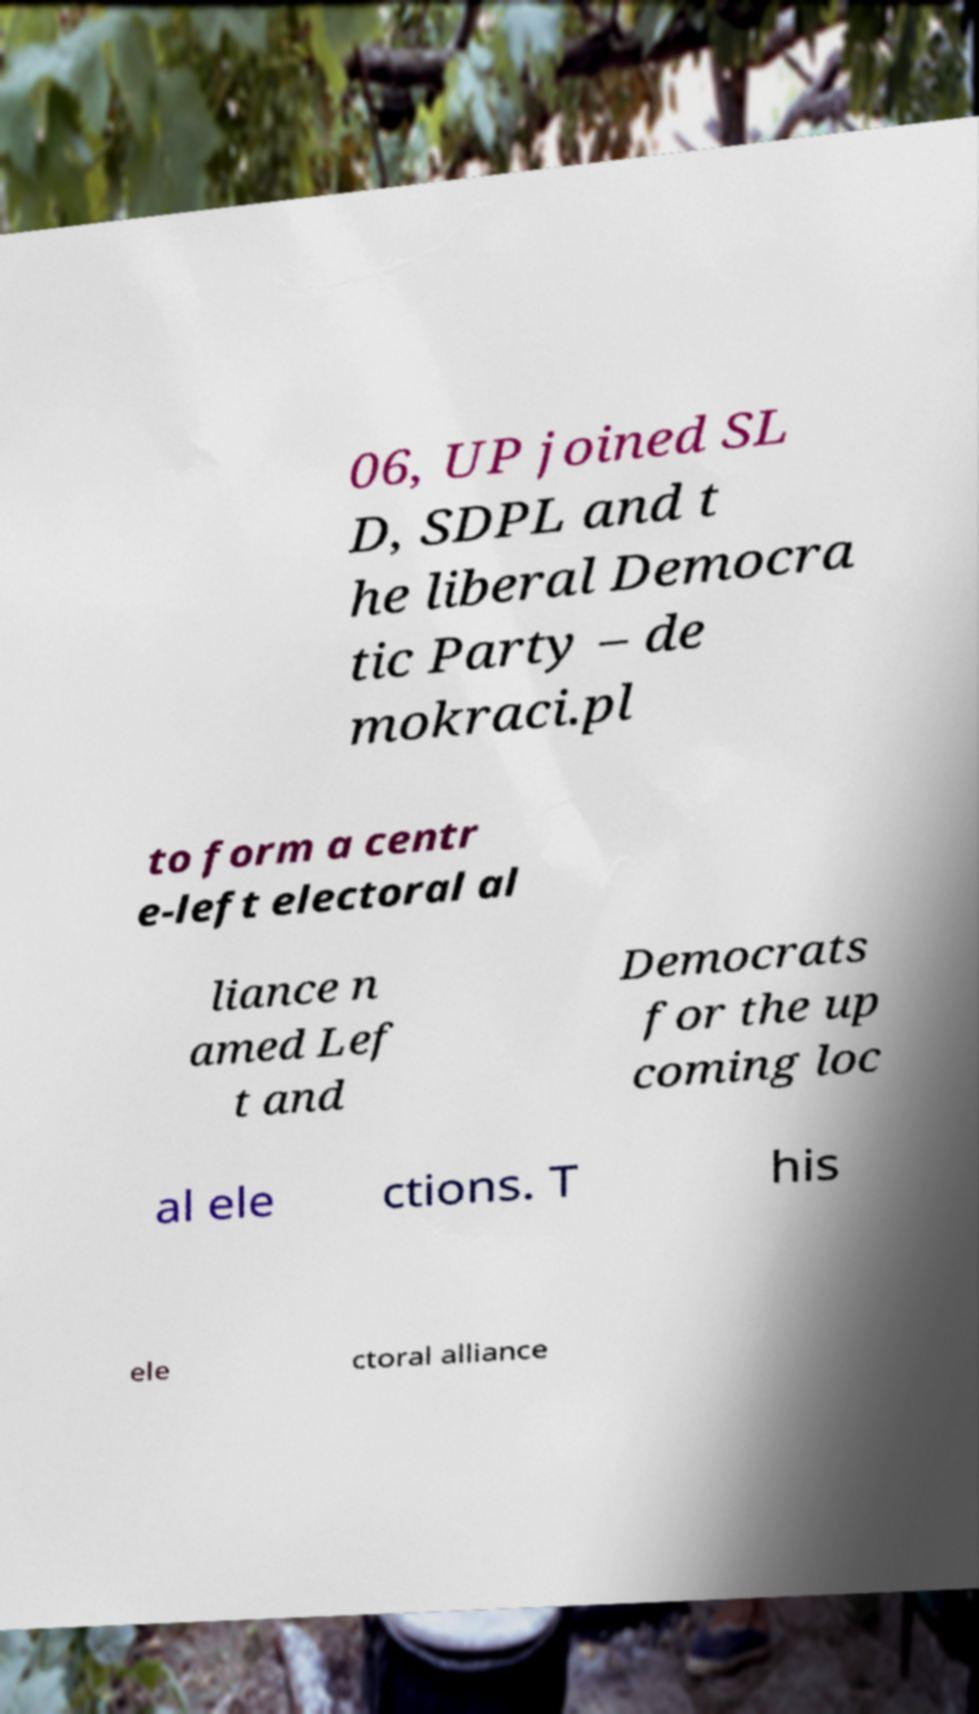I need the written content from this picture converted into text. Can you do that? 06, UP joined SL D, SDPL and t he liberal Democra tic Party – de mokraci.pl to form a centr e-left electoral al liance n amed Lef t and Democrats for the up coming loc al ele ctions. T his ele ctoral alliance 